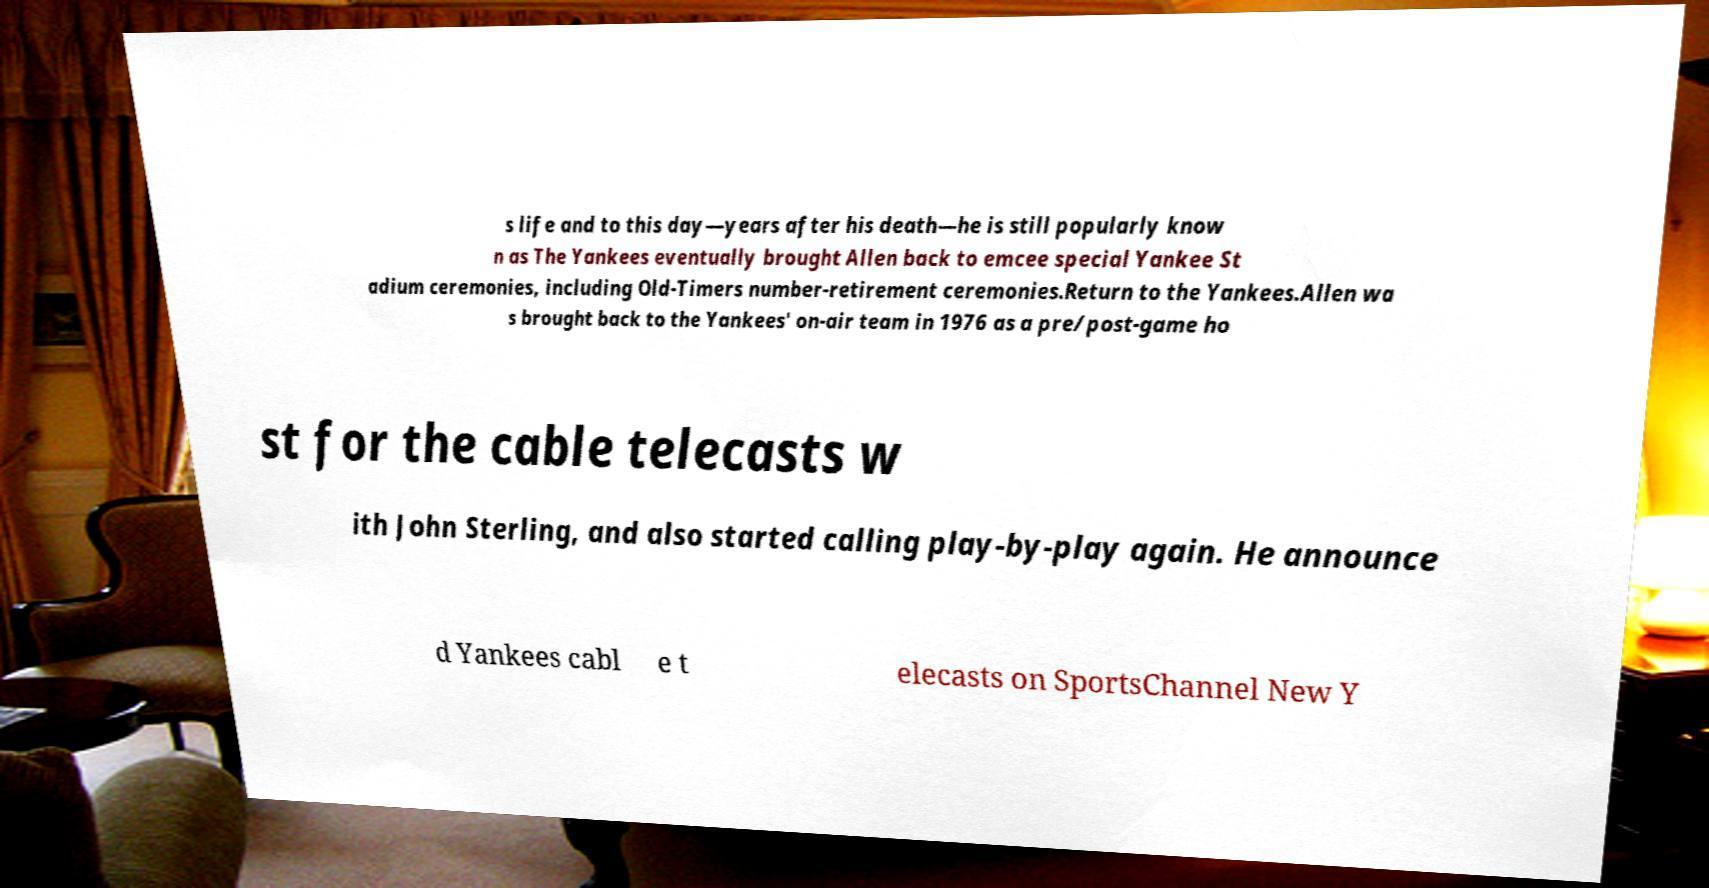Could you assist in decoding the text presented in this image and type it out clearly? s life and to this day—years after his death—he is still popularly know n as The Yankees eventually brought Allen back to emcee special Yankee St adium ceremonies, including Old-Timers number-retirement ceremonies.Return to the Yankees.Allen wa s brought back to the Yankees' on-air team in 1976 as a pre/post-game ho st for the cable telecasts w ith John Sterling, and also started calling play-by-play again. He announce d Yankees cabl e t elecasts on SportsChannel New Y 